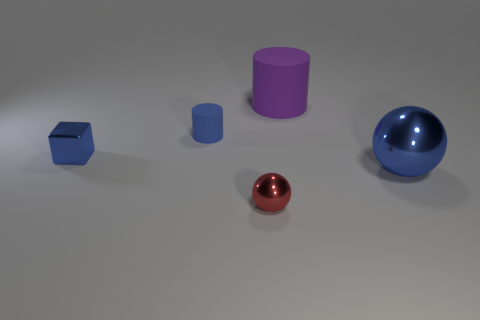Can you describe the lighting in this scene? The scene is lit from above with a diffused light source, casting soft shadows underneath the objects, which contributes to the calm and balanced atmosphere of the image. 